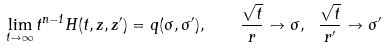<formula> <loc_0><loc_0><loc_500><loc_500>\lim _ { t \to \infty } t ^ { n - 1 } H ( t , z , z ^ { \prime } ) = q ( \sigma , \sigma ^ { \prime } ) , \quad \frac { \sqrt { t } } { r } \to \sigma , \ \frac { \sqrt { t } } { r ^ { \prime } } \to \sigma ^ { \prime }</formula> 